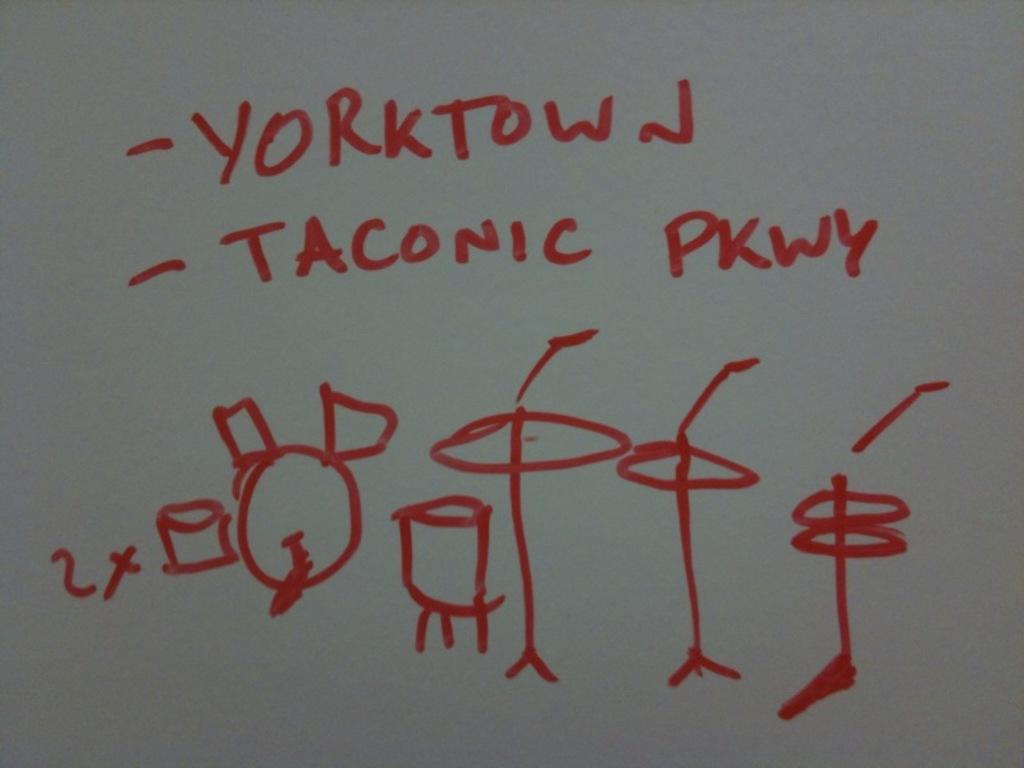<image>
Describe the image concisely. Someone has written Yorktown over a drawing of a drum set. 